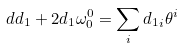Convert formula to latex. <formula><loc_0><loc_0><loc_500><loc_500>d d _ { 1 } + 2 d _ { 1 } \omega ^ { 0 } _ { 0 } = \sum _ { i } { d _ { 1 } } _ { i } \theta ^ { i }</formula> 